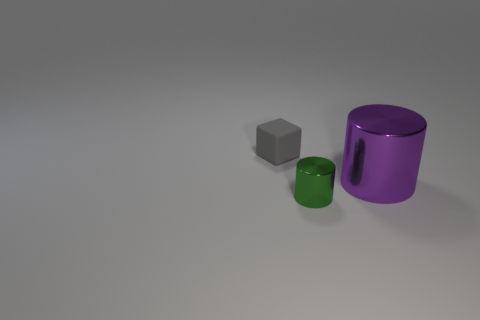Add 1 gray shiny cubes. How many objects exist? 4 Subtract all green cylinders. How many cylinders are left? 1 Subtract all cylinders. How many objects are left? 1 Subtract 0 brown blocks. How many objects are left? 3 Subtract all red cylinders. Subtract all brown balls. How many cylinders are left? 2 Subtract all yellow cylinders. Subtract all green objects. How many objects are left? 2 Add 1 big cylinders. How many big cylinders are left? 2 Add 1 green metal things. How many green metal things exist? 2 